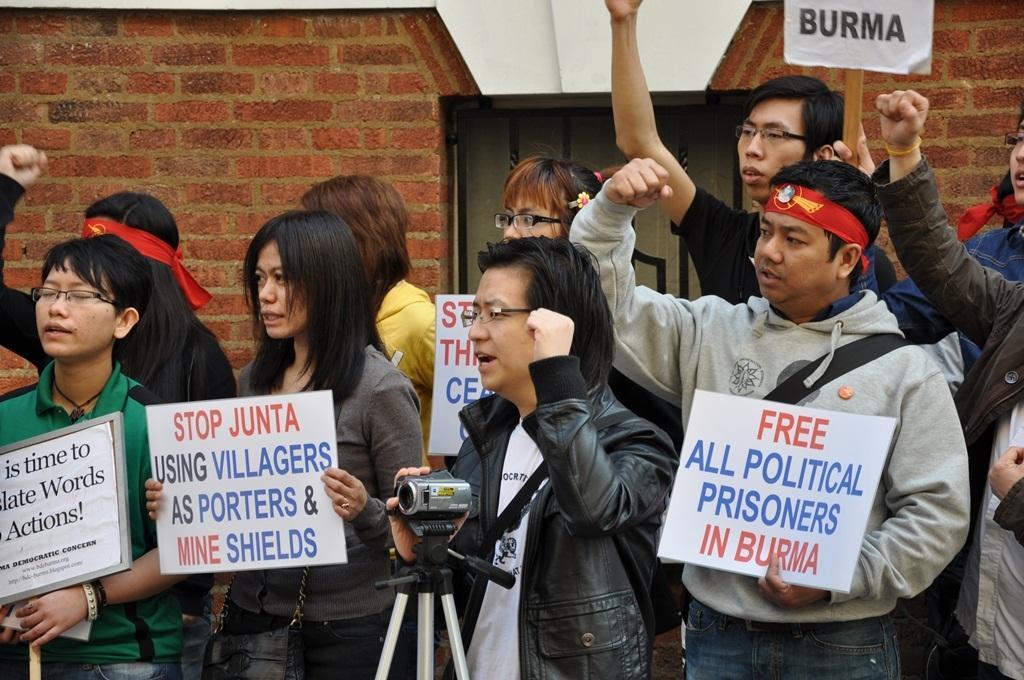Can you describe this image briefly? In the picture there is a group of people gathered in an area and they are protesting against something and they are holding some posters with their hands, one person is holding a camera and behind the people there is a brick wall in the background. 